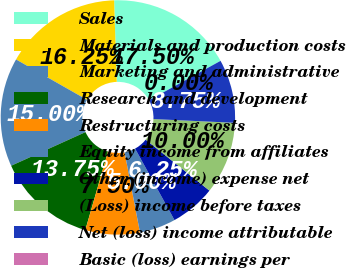<chart> <loc_0><loc_0><loc_500><loc_500><pie_chart><fcel>Sales<fcel>Materials and production costs<fcel>Marketing and administrative<fcel>Research and development<fcel>Restructuring costs<fcel>Equity income from affiliates<fcel>Other (income) expense net<fcel>(Loss) income before taxes<fcel>Net (loss) income attributable<fcel>Basic (loss) earnings per<nl><fcel>17.5%<fcel>16.25%<fcel>15.0%<fcel>13.75%<fcel>7.5%<fcel>5.0%<fcel>6.25%<fcel>10.0%<fcel>8.75%<fcel>0.0%<nl></chart> 